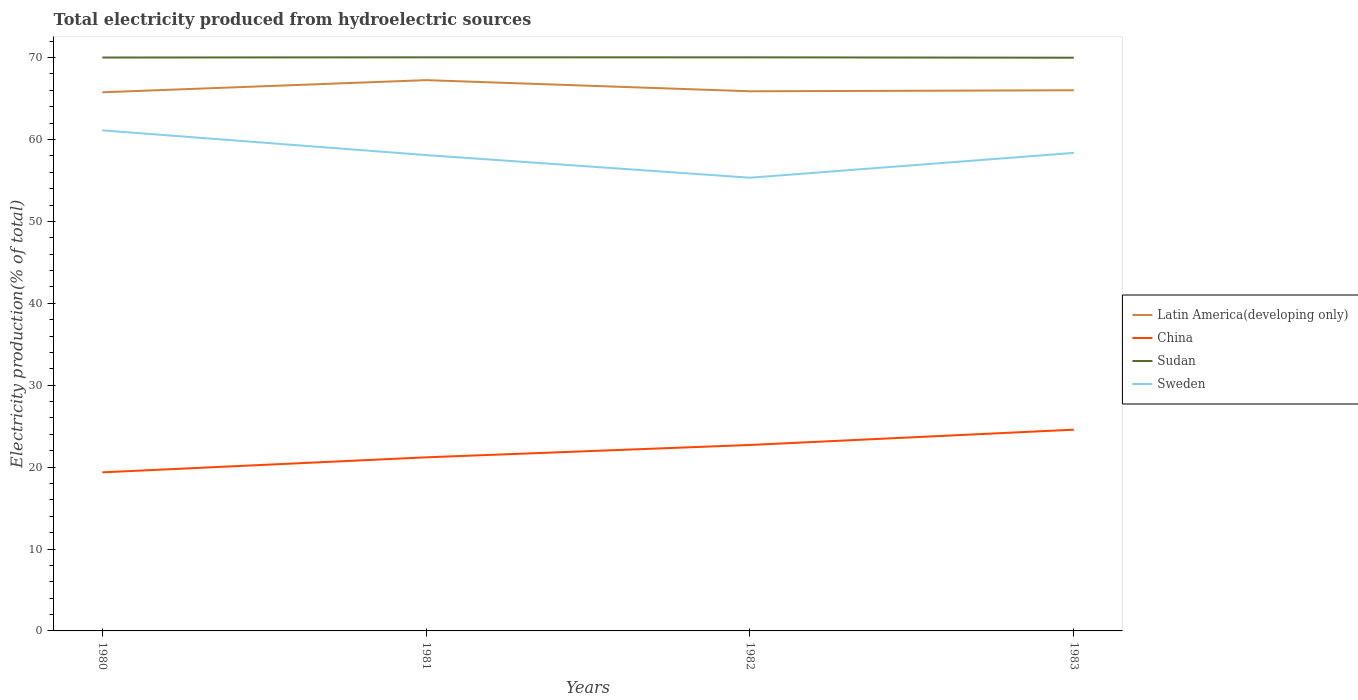How many different coloured lines are there?
Provide a short and direct response. 4. Does the line corresponding to Sudan intersect with the line corresponding to Sweden?
Your answer should be compact. No. Is the number of lines equal to the number of legend labels?
Give a very brief answer. Yes. Across all years, what is the maximum total electricity produced in Sweden?
Offer a very short reply. 55.34. What is the total total electricity produced in China in the graph?
Offer a very short reply. -3.34. What is the difference between the highest and the second highest total electricity produced in Latin America(developing only)?
Offer a very short reply. 1.48. What is the difference between the highest and the lowest total electricity produced in Latin America(developing only)?
Offer a terse response. 1. Is the total electricity produced in China strictly greater than the total electricity produced in Sudan over the years?
Your answer should be compact. Yes. How many lines are there?
Keep it short and to the point. 4. Does the graph contain any zero values?
Ensure brevity in your answer.  No. Does the graph contain grids?
Make the answer very short. No. Where does the legend appear in the graph?
Your response must be concise. Center right. What is the title of the graph?
Your answer should be very brief. Total electricity produced from hydroelectric sources. Does "Oman" appear as one of the legend labels in the graph?
Your answer should be very brief. No. What is the Electricity production(% of total) of Latin America(developing only) in 1980?
Ensure brevity in your answer.  65.77. What is the Electricity production(% of total) in China in 1980?
Make the answer very short. 19.36. What is the Electricity production(% of total) in Sudan in 1980?
Provide a succinct answer. 70.01. What is the Electricity production(% of total) in Sweden in 1980?
Your answer should be very brief. 61.12. What is the Electricity production(% of total) of Latin America(developing only) in 1981?
Provide a succinct answer. 67.25. What is the Electricity production(% of total) in China in 1981?
Provide a succinct answer. 21.2. What is the Electricity production(% of total) of Sudan in 1981?
Provide a succinct answer. 70.04. What is the Electricity production(% of total) in Sweden in 1981?
Your answer should be very brief. 58.1. What is the Electricity production(% of total) of Latin America(developing only) in 1982?
Your response must be concise. 65.89. What is the Electricity production(% of total) in China in 1982?
Keep it short and to the point. 22.71. What is the Electricity production(% of total) in Sudan in 1982?
Offer a terse response. 70.03. What is the Electricity production(% of total) of Sweden in 1982?
Make the answer very short. 55.34. What is the Electricity production(% of total) in Latin America(developing only) in 1983?
Offer a very short reply. 66.01. What is the Electricity production(% of total) of China in 1983?
Provide a succinct answer. 24.57. What is the Electricity production(% of total) of Sudan in 1983?
Your answer should be very brief. 69.99. What is the Electricity production(% of total) in Sweden in 1983?
Keep it short and to the point. 58.37. Across all years, what is the maximum Electricity production(% of total) in Latin America(developing only)?
Offer a very short reply. 67.25. Across all years, what is the maximum Electricity production(% of total) in China?
Provide a succinct answer. 24.57. Across all years, what is the maximum Electricity production(% of total) of Sudan?
Give a very brief answer. 70.04. Across all years, what is the maximum Electricity production(% of total) of Sweden?
Offer a very short reply. 61.12. Across all years, what is the minimum Electricity production(% of total) in Latin America(developing only)?
Provide a short and direct response. 65.77. Across all years, what is the minimum Electricity production(% of total) in China?
Offer a very short reply. 19.36. Across all years, what is the minimum Electricity production(% of total) in Sudan?
Your answer should be compact. 69.99. Across all years, what is the minimum Electricity production(% of total) in Sweden?
Give a very brief answer. 55.34. What is the total Electricity production(% of total) in Latin America(developing only) in the graph?
Your response must be concise. 264.92. What is the total Electricity production(% of total) in China in the graph?
Provide a succinct answer. 87.84. What is the total Electricity production(% of total) of Sudan in the graph?
Your response must be concise. 280.07. What is the total Electricity production(% of total) of Sweden in the graph?
Make the answer very short. 232.92. What is the difference between the Electricity production(% of total) of Latin America(developing only) in 1980 and that in 1981?
Make the answer very short. -1.48. What is the difference between the Electricity production(% of total) of China in 1980 and that in 1981?
Make the answer very short. -1.83. What is the difference between the Electricity production(% of total) of Sudan in 1980 and that in 1981?
Your response must be concise. -0.02. What is the difference between the Electricity production(% of total) of Sweden in 1980 and that in 1981?
Offer a terse response. 3.02. What is the difference between the Electricity production(% of total) of Latin America(developing only) in 1980 and that in 1982?
Your response must be concise. -0.12. What is the difference between the Electricity production(% of total) of China in 1980 and that in 1982?
Your answer should be very brief. -3.34. What is the difference between the Electricity production(% of total) of Sudan in 1980 and that in 1982?
Offer a terse response. -0.02. What is the difference between the Electricity production(% of total) in Sweden in 1980 and that in 1982?
Make the answer very short. 5.78. What is the difference between the Electricity production(% of total) in Latin America(developing only) in 1980 and that in 1983?
Your response must be concise. -0.25. What is the difference between the Electricity production(% of total) in China in 1980 and that in 1983?
Provide a succinct answer. -5.21. What is the difference between the Electricity production(% of total) in Sudan in 1980 and that in 1983?
Your answer should be compact. 0.02. What is the difference between the Electricity production(% of total) of Sweden in 1980 and that in 1983?
Your answer should be compact. 2.75. What is the difference between the Electricity production(% of total) of Latin America(developing only) in 1981 and that in 1982?
Make the answer very short. 1.36. What is the difference between the Electricity production(% of total) in China in 1981 and that in 1982?
Give a very brief answer. -1.51. What is the difference between the Electricity production(% of total) in Sudan in 1981 and that in 1982?
Your response must be concise. 0. What is the difference between the Electricity production(% of total) of Sweden in 1981 and that in 1982?
Provide a short and direct response. 2.76. What is the difference between the Electricity production(% of total) in Latin America(developing only) in 1981 and that in 1983?
Ensure brevity in your answer.  1.24. What is the difference between the Electricity production(% of total) in China in 1981 and that in 1983?
Make the answer very short. -3.38. What is the difference between the Electricity production(% of total) of Sudan in 1981 and that in 1983?
Provide a short and direct response. 0.05. What is the difference between the Electricity production(% of total) of Sweden in 1981 and that in 1983?
Your response must be concise. -0.27. What is the difference between the Electricity production(% of total) of Latin America(developing only) in 1982 and that in 1983?
Give a very brief answer. -0.12. What is the difference between the Electricity production(% of total) in China in 1982 and that in 1983?
Provide a short and direct response. -1.87. What is the difference between the Electricity production(% of total) in Sudan in 1982 and that in 1983?
Provide a short and direct response. 0.04. What is the difference between the Electricity production(% of total) of Sweden in 1982 and that in 1983?
Ensure brevity in your answer.  -3.03. What is the difference between the Electricity production(% of total) in Latin America(developing only) in 1980 and the Electricity production(% of total) in China in 1981?
Give a very brief answer. 44.57. What is the difference between the Electricity production(% of total) of Latin America(developing only) in 1980 and the Electricity production(% of total) of Sudan in 1981?
Provide a succinct answer. -4.27. What is the difference between the Electricity production(% of total) of Latin America(developing only) in 1980 and the Electricity production(% of total) of Sweden in 1981?
Ensure brevity in your answer.  7.67. What is the difference between the Electricity production(% of total) in China in 1980 and the Electricity production(% of total) in Sudan in 1981?
Make the answer very short. -50.67. What is the difference between the Electricity production(% of total) of China in 1980 and the Electricity production(% of total) of Sweden in 1981?
Provide a succinct answer. -38.74. What is the difference between the Electricity production(% of total) in Sudan in 1980 and the Electricity production(% of total) in Sweden in 1981?
Your response must be concise. 11.91. What is the difference between the Electricity production(% of total) of Latin America(developing only) in 1980 and the Electricity production(% of total) of China in 1982?
Give a very brief answer. 43.06. What is the difference between the Electricity production(% of total) of Latin America(developing only) in 1980 and the Electricity production(% of total) of Sudan in 1982?
Ensure brevity in your answer.  -4.27. What is the difference between the Electricity production(% of total) in Latin America(developing only) in 1980 and the Electricity production(% of total) in Sweden in 1982?
Your answer should be very brief. 10.43. What is the difference between the Electricity production(% of total) in China in 1980 and the Electricity production(% of total) in Sudan in 1982?
Give a very brief answer. -50.67. What is the difference between the Electricity production(% of total) of China in 1980 and the Electricity production(% of total) of Sweden in 1982?
Make the answer very short. -35.97. What is the difference between the Electricity production(% of total) in Sudan in 1980 and the Electricity production(% of total) in Sweden in 1982?
Offer a terse response. 14.68. What is the difference between the Electricity production(% of total) in Latin America(developing only) in 1980 and the Electricity production(% of total) in China in 1983?
Your answer should be compact. 41.19. What is the difference between the Electricity production(% of total) in Latin America(developing only) in 1980 and the Electricity production(% of total) in Sudan in 1983?
Make the answer very short. -4.22. What is the difference between the Electricity production(% of total) in Latin America(developing only) in 1980 and the Electricity production(% of total) in Sweden in 1983?
Offer a very short reply. 7.4. What is the difference between the Electricity production(% of total) of China in 1980 and the Electricity production(% of total) of Sudan in 1983?
Your answer should be very brief. -50.63. What is the difference between the Electricity production(% of total) of China in 1980 and the Electricity production(% of total) of Sweden in 1983?
Offer a very short reply. -39. What is the difference between the Electricity production(% of total) of Sudan in 1980 and the Electricity production(% of total) of Sweden in 1983?
Provide a succinct answer. 11.64. What is the difference between the Electricity production(% of total) in Latin America(developing only) in 1981 and the Electricity production(% of total) in China in 1982?
Your answer should be very brief. 44.55. What is the difference between the Electricity production(% of total) of Latin America(developing only) in 1981 and the Electricity production(% of total) of Sudan in 1982?
Offer a terse response. -2.78. What is the difference between the Electricity production(% of total) of Latin America(developing only) in 1981 and the Electricity production(% of total) of Sweden in 1982?
Your answer should be very brief. 11.91. What is the difference between the Electricity production(% of total) in China in 1981 and the Electricity production(% of total) in Sudan in 1982?
Make the answer very short. -48.84. What is the difference between the Electricity production(% of total) of China in 1981 and the Electricity production(% of total) of Sweden in 1982?
Your answer should be very brief. -34.14. What is the difference between the Electricity production(% of total) of Sudan in 1981 and the Electricity production(% of total) of Sweden in 1982?
Make the answer very short. 14.7. What is the difference between the Electricity production(% of total) in Latin America(developing only) in 1981 and the Electricity production(% of total) in China in 1983?
Offer a very short reply. 42.68. What is the difference between the Electricity production(% of total) of Latin America(developing only) in 1981 and the Electricity production(% of total) of Sudan in 1983?
Make the answer very short. -2.74. What is the difference between the Electricity production(% of total) of Latin America(developing only) in 1981 and the Electricity production(% of total) of Sweden in 1983?
Make the answer very short. 8.88. What is the difference between the Electricity production(% of total) of China in 1981 and the Electricity production(% of total) of Sudan in 1983?
Your answer should be very brief. -48.79. What is the difference between the Electricity production(% of total) in China in 1981 and the Electricity production(% of total) in Sweden in 1983?
Make the answer very short. -37.17. What is the difference between the Electricity production(% of total) in Sudan in 1981 and the Electricity production(% of total) in Sweden in 1983?
Your answer should be compact. 11.67. What is the difference between the Electricity production(% of total) of Latin America(developing only) in 1982 and the Electricity production(% of total) of China in 1983?
Give a very brief answer. 41.32. What is the difference between the Electricity production(% of total) in Latin America(developing only) in 1982 and the Electricity production(% of total) in Sudan in 1983?
Make the answer very short. -4.1. What is the difference between the Electricity production(% of total) in Latin America(developing only) in 1982 and the Electricity production(% of total) in Sweden in 1983?
Give a very brief answer. 7.52. What is the difference between the Electricity production(% of total) of China in 1982 and the Electricity production(% of total) of Sudan in 1983?
Provide a short and direct response. -47.28. What is the difference between the Electricity production(% of total) in China in 1982 and the Electricity production(% of total) in Sweden in 1983?
Give a very brief answer. -35.66. What is the difference between the Electricity production(% of total) in Sudan in 1982 and the Electricity production(% of total) in Sweden in 1983?
Offer a very short reply. 11.67. What is the average Electricity production(% of total) of Latin America(developing only) per year?
Offer a very short reply. 66.23. What is the average Electricity production(% of total) in China per year?
Your response must be concise. 21.96. What is the average Electricity production(% of total) of Sudan per year?
Ensure brevity in your answer.  70.02. What is the average Electricity production(% of total) of Sweden per year?
Keep it short and to the point. 58.23. In the year 1980, what is the difference between the Electricity production(% of total) of Latin America(developing only) and Electricity production(% of total) of China?
Keep it short and to the point. 46.41. In the year 1980, what is the difference between the Electricity production(% of total) in Latin America(developing only) and Electricity production(% of total) in Sudan?
Provide a succinct answer. -4.24. In the year 1980, what is the difference between the Electricity production(% of total) in Latin America(developing only) and Electricity production(% of total) in Sweden?
Offer a very short reply. 4.65. In the year 1980, what is the difference between the Electricity production(% of total) of China and Electricity production(% of total) of Sudan?
Make the answer very short. -50.65. In the year 1980, what is the difference between the Electricity production(% of total) of China and Electricity production(% of total) of Sweden?
Keep it short and to the point. -41.76. In the year 1980, what is the difference between the Electricity production(% of total) in Sudan and Electricity production(% of total) in Sweden?
Your answer should be compact. 8.89. In the year 1981, what is the difference between the Electricity production(% of total) in Latin America(developing only) and Electricity production(% of total) in China?
Make the answer very short. 46.06. In the year 1981, what is the difference between the Electricity production(% of total) in Latin America(developing only) and Electricity production(% of total) in Sudan?
Give a very brief answer. -2.79. In the year 1981, what is the difference between the Electricity production(% of total) of Latin America(developing only) and Electricity production(% of total) of Sweden?
Provide a succinct answer. 9.15. In the year 1981, what is the difference between the Electricity production(% of total) of China and Electricity production(% of total) of Sudan?
Provide a short and direct response. -48.84. In the year 1981, what is the difference between the Electricity production(% of total) in China and Electricity production(% of total) in Sweden?
Your answer should be very brief. -36.9. In the year 1981, what is the difference between the Electricity production(% of total) in Sudan and Electricity production(% of total) in Sweden?
Keep it short and to the point. 11.94. In the year 1982, what is the difference between the Electricity production(% of total) of Latin America(developing only) and Electricity production(% of total) of China?
Keep it short and to the point. 43.18. In the year 1982, what is the difference between the Electricity production(% of total) of Latin America(developing only) and Electricity production(% of total) of Sudan?
Offer a terse response. -4.14. In the year 1982, what is the difference between the Electricity production(% of total) in Latin America(developing only) and Electricity production(% of total) in Sweden?
Offer a very short reply. 10.55. In the year 1982, what is the difference between the Electricity production(% of total) in China and Electricity production(% of total) in Sudan?
Offer a terse response. -47.33. In the year 1982, what is the difference between the Electricity production(% of total) in China and Electricity production(% of total) in Sweden?
Offer a terse response. -32.63. In the year 1982, what is the difference between the Electricity production(% of total) in Sudan and Electricity production(% of total) in Sweden?
Offer a very short reply. 14.7. In the year 1983, what is the difference between the Electricity production(% of total) of Latin America(developing only) and Electricity production(% of total) of China?
Offer a very short reply. 41.44. In the year 1983, what is the difference between the Electricity production(% of total) in Latin America(developing only) and Electricity production(% of total) in Sudan?
Your answer should be compact. -3.98. In the year 1983, what is the difference between the Electricity production(% of total) in Latin America(developing only) and Electricity production(% of total) in Sweden?
Your response must be concise. 7.65. In the year 1983, what is the difference between the Electricity production(% of total) in China and Electricity production(% of total) in Sudan?
Offer a terse response. -45.42. In the year 1983, what is the difference between the Electricity production(% of total) in China and Electricity production(% of total) in Sweden?
Your answer should be very brief. -33.79. In the year 1983, what is the difference between the Electricity production(% of total) of Sudan and Electricity production(% of total) of Sweden?
Keep it short and to the point. 11.62. What is the ratio of the Electricity production(% of total) in China in 1980 to that in 1981?
Offer a very short reply. 0.91. What is the ratio of the Electricity production(% of total) of Sweden in 1980 to that in 1981?
Keep it short and to the point. 1.05. What is the ratio of the Electricity production(% of total) in China in 1980 to that in 1982?
Ensure brevity in your answer.  0.85. What is the ratio of the Electricity production(% of total) of Sweden in 1980 to that in 1982?
Your answer should be very brief. 1.1. What is the ratio of the Electricity production(% of total) of Latin America(developing only) in 1980 to that in 1983?
Your response must be concise. 1. What is the ratio of the Electricity production(% of total) in China in 1980 to that in 1983?
Your answer should be compact. 0.79. What is the ratio of the Electricity production(% of total) of Sudan in 1980 to that in 1983?
Ensure brevity in your answer.  1. What is the ratio of the Electricity production(% of total) of Sweden in 1980 to that in 1983?
Provide a succinct answer. 1.05. What is the ratio of the Electricity production(% of total) of Latin America(developing only) in 1981 to that in 1982?
Provide a short and direct response. 1.02. What is the ratio of the Electricity production(% of total) in China in 1981 to that in 1982?
Provide a succinct answer. 0.93. What is the ratio of the Electricity production(% of total) in Sweden in 1981 to that in 1982?
Provide a short and direct response. 1.05. What is the ratio of the Electricity production(% of total) in Latin America(developing only) in 1981 to that in 1983?
Make the answer very short. 1.02. What is the ratio of the Electricity production(% of total) of China in 1981 to that in 1983?
Provide a short and direct response. 0.86. What is the ratio of the Electricity production(% of total) of Latin America(developing only) in 1982 to that in 1983?
Keep it short and to the point. 1. What is the ratio of the Electricity production(% of total) of China in 1982 to that in 1983?
Your response must be concise. 0.92. What is the ratio of the Electricity production(% of total) in Sweden in 1982 to that in 1983?
Make the answer very short. 0.95. What is the difference between the highest and the second highest Electricity production(% of total) in Latin America(developing only)?
Provide a succinct answer. 1.24. What is the difference between the highest and the second highest Electricity production(% of total) in China?
Your response must be concise. 1.87. What is the difference between the highest and the second highest Electricity production(% of total) of Sudan?
Offer a very short reply. 0. What is the difference between the highest and the second highest Electricity production(% of total) in Sweden?
Provide a short and direct response. 2.75. What is the difference between the highest and the lowest Electricity production(% of total) of Latin America(developing only)?
Keep it short and to the point. 1.48. What is the difference between the highest and the lowest Electricity production(% of total) of China?
Offer a terse response. 5.21. What is the difference between the highest and the lowest Electricity production(% of total) of Sudan?
Your answer should be very brief. 0.05. What is the difference between the highest and the lowest Electricity production(% of total) in Sweden?
Offer a terse response. 5.78. 